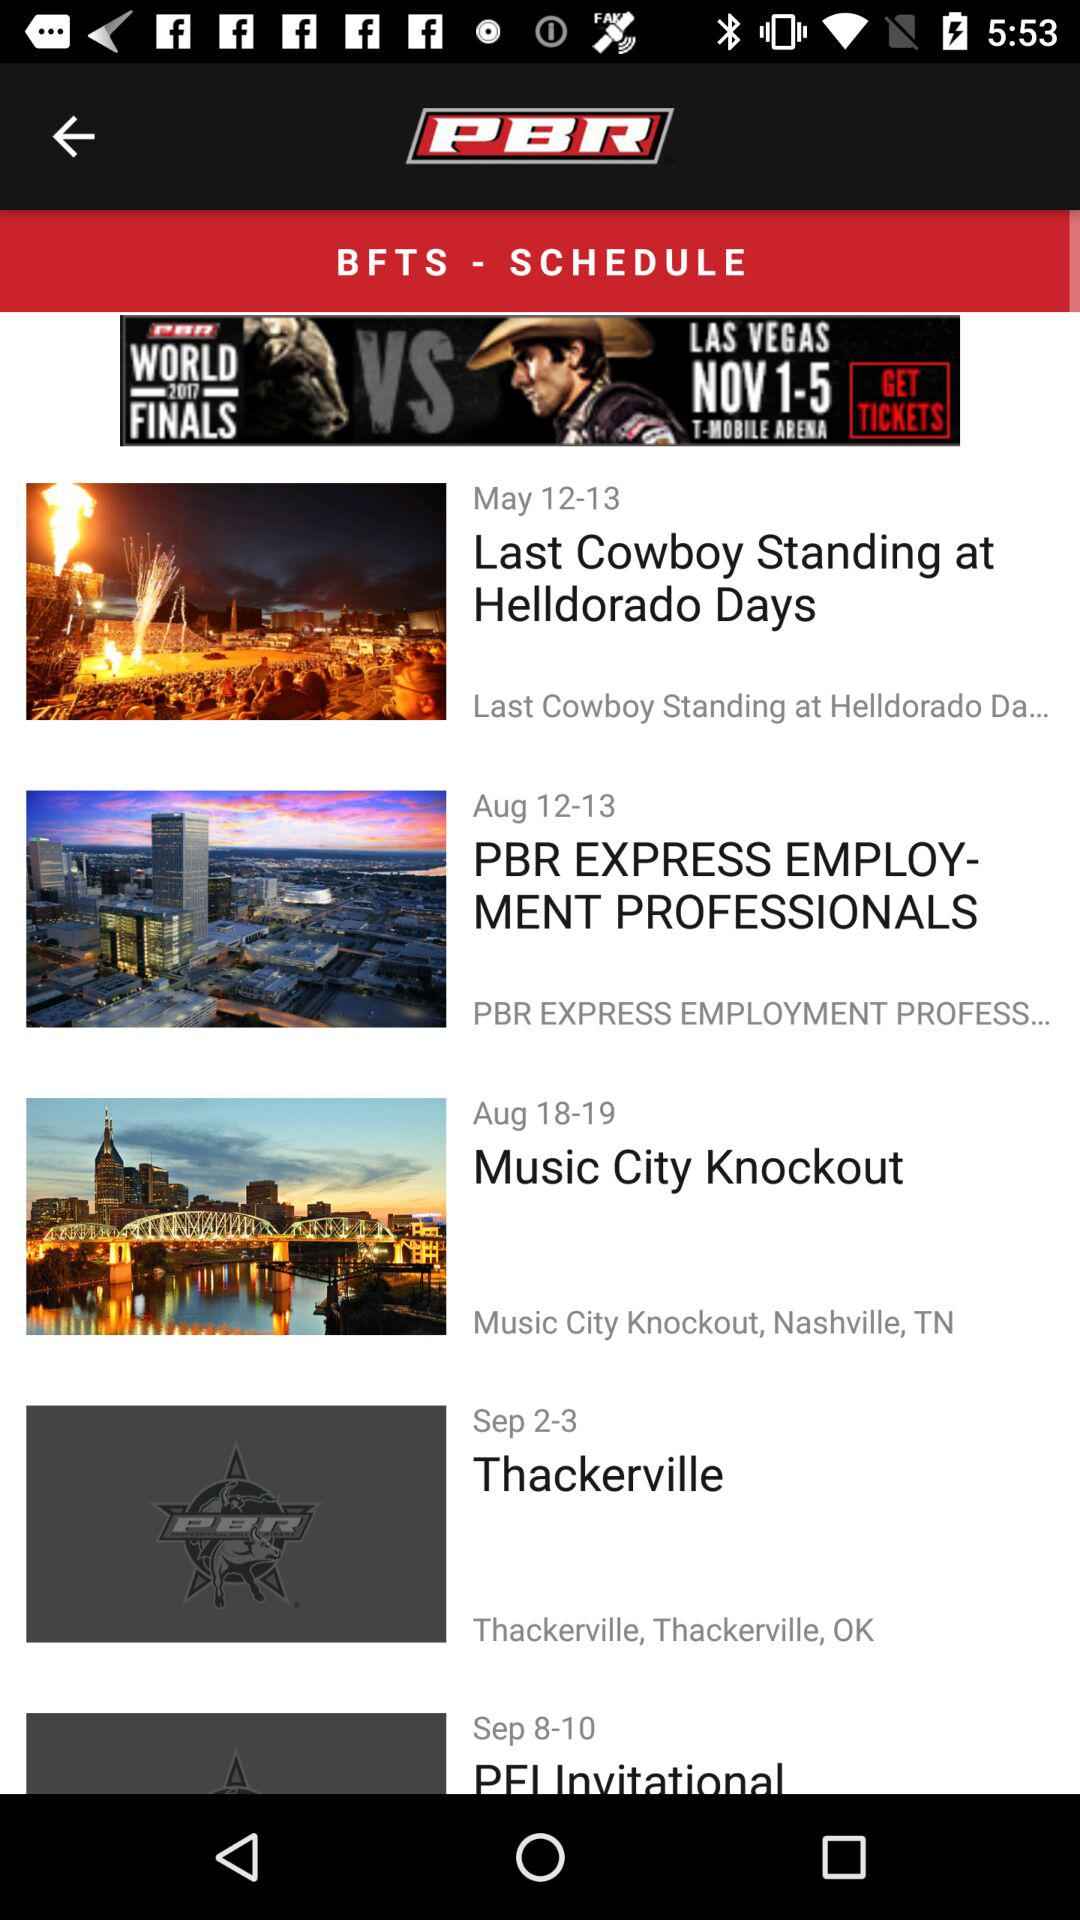When will the "Music City Knockout" be released? The "Music City Knockout" will be released on August 18-19. 